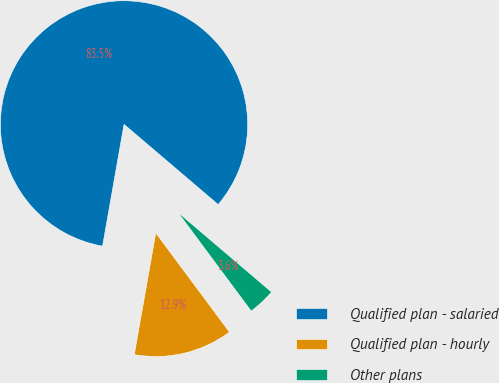Convert chart. <chart><loc_0><loc_0><loc_500><loc_500><pie_chart><fcel>Qualified plan - salaried<fcel>Qualified plan - hourly<fcel>Other plans<nl><fcel>83.45%<fcel>12.95%<fcel>3.6%<nl></chart> 